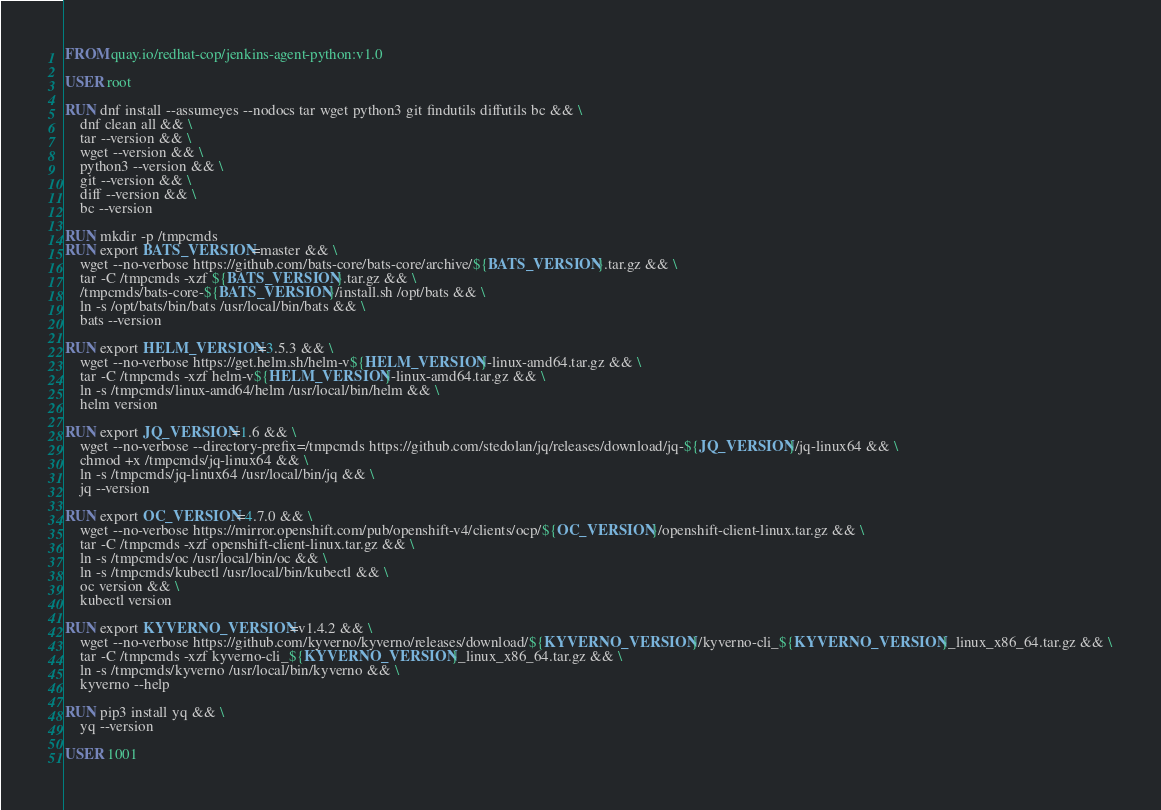Convert code to text. <code><loc_0><loc_0><loc_500><loc_500><_Dockerfile_>FROM quay.io/redhat-cop/jenkins-agent-python:v1.0

USER root

RUN dnf install --assumeyes --nodocs tar wget python3 git findutils diffutils bc && \
    dnf clean all && \
    tar --version && \
    wget --version && \
    python3 --version && \
    git --version && \
    diff --version && \
    bc --version

RUN mkdir -p /tmpcmds
RUN export BATS_VERSION=master && \
    wget --no-verbose https://github.com/bats-core/bats-core/archive/${BATS_VERSION}.tar.gz && \
    tar -C /tmpcmds -xzf ${BATS_VERSION}.tar.gz && \
    /tmpcmds/bats-core-${BATS_VERSION}/install.sh /opt/bats && \
    ln -s /opt/bats/bin/bats /usr/local/bin/bats && \
    bats --version

RUN export HELM_VERSION=3.5.3 && \
    wget --no-verbose https://get.helm.sh/helm-v${HELM_VERSION}-linux-amd64.tar.gz && \
    tar -C /tmpcmds -xzf helm-v${HELM_VERSION}-linux-amd64.tar.gz && \
    ln -s /tmpcmds/linux-amd64/helm /usr/local/bin/helm && \
    helm version

RUN export JQ_VERSION=1.6 && \
    wget --no-verbose --directory-prefix=/tmpcmds https://github.com/stedolan/jq/releases/download/jq-${JQ_VERSION}/jq-linux64 && \
    chmod +x /tmpcmds/jq-linux64 && \
    ln -s /tmpcmds/jq-linux64 /usr/local/bin/jq && \
    jq --version

RUN export OC_VERSION=4.7.0 && \
    wget --no-verbose https://mirror.openshift.com/pub/openshift-v4/clients/ocp/${OC_VERSION}/openshift-client-linux.tar.gz && \
    tar -C /tmpcmds -xzf openshift-client-linux.tar.gz && \
    ln -s /tmpcmds/oc /usr/local/bin/oc && \
    ln -s /tmpcmds/kubectl /usr/local/bin/kubectl && \
    oc version && \
    kubectl version

RUN export KYVERNO_VERSION=v1.4.2 && \
    wget --no-verbose https://github.com/kyverno/kyverno/releases/download/${KYVERNO_VERSION}/kyverno-cli_${KYVERNO_VERSION}_linux_x86_64.tar.gz && \
    tar -C /tmpcmds -xzf kyverno-cli_${KYVERNO_VERSION}_linux_x86_64.tar.gz && \
    ln -s /tmpcmds/kyverno /usr/local/bin/kyverno && \
    kyverno --help

RUN pip3 install yq && \
    yq --version

USER 1001</code> 